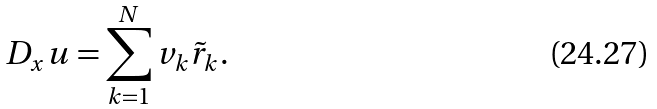Convert formula to latex. <formula><loc_0><loc_0><loc_500><loc_500>D _ { x } u = \sum _ { k = 1 } ^ { N } v _ { k } \tilde { r } _ { k } .</formula> 